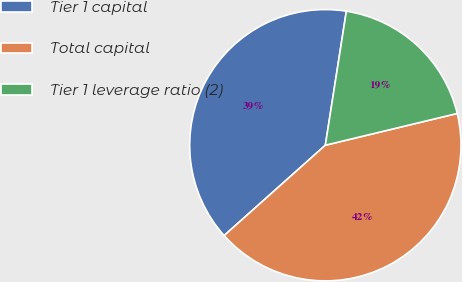<chart> <loc_0><loc_0><loc_500><loc_500><pie_chart><fcel>Tier 1 capital<fcel>Total capital<fcel>Tier 1 leverage ratio (2)<nl><fcel>39.07%<fcel>42.16%<fcel>18.76%<nl></chart> 